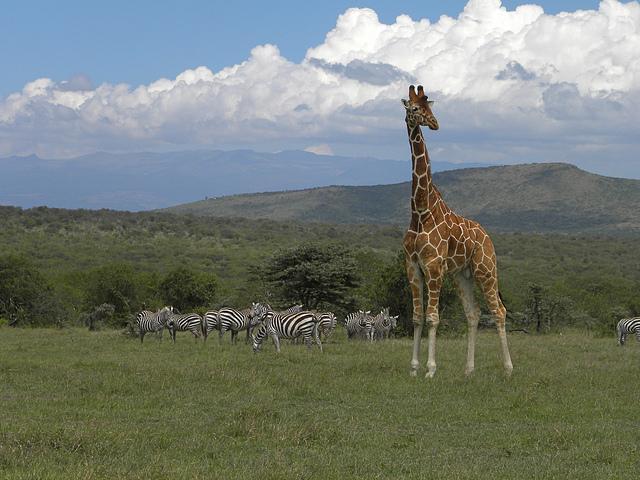How many giraffes are there?
Give a very brief answer. 1. How many different animals are there?
Give a very brief answer. 2. 